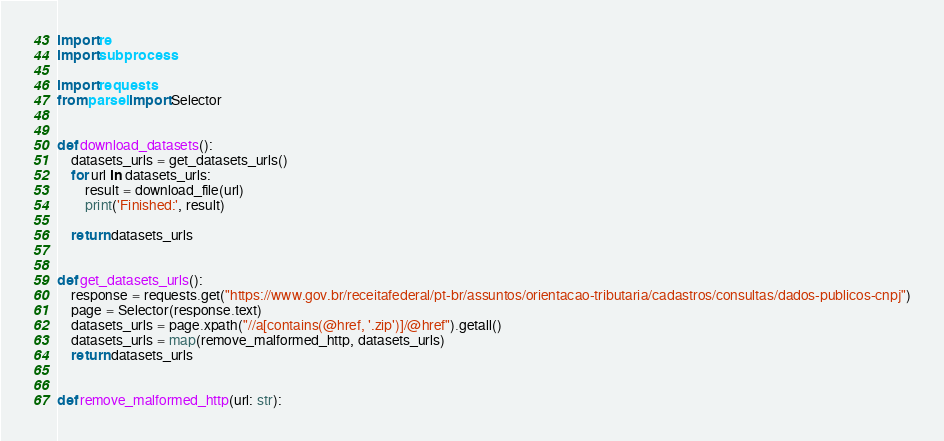<code> <loc_0><loc_0><loc_500><loc_500><_Python_>import re
import subprocess

import requests
from parsel import Selector


def download_datasets():
    datasets_urls = get_datasets_urls()
    for url in datasets_urls:
        result = download_file(url)
        print('Finished:', result)

    return datasets_urls


def get_datasets_urls():
    response = requests.get("https://www.gov.br/receitafederal/pt-br/assuntos/orientacao-tributaria/cadastros/consultas/dados-publicos-cnpj")
    page = Selector(response.text)
    datasets_urls = page.xpath("//a[contains(@href, '.zip')]/@href").getall()
    datasets_urls = map(remove_malformed_http, datasets_urls)
    return datasets_urls


def remove_malformed_http(url: str):</code> 